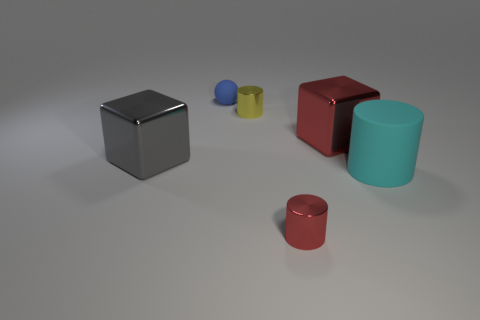Subtract all tiny cylinders. How many cylinders are left? 1 Add 1 large purple spheres. How many objects exist? 7 Subtract all cubes. How many objects are left? 4 Subtract 1 gray cubes. How many objects are left? 5 Subtract all blocks. Subtract all big gray metallic blocks. How many objects are left? 3 Add 6 big gray metallic objects. How many big gray metallic objects are left? 7 Add 5 large cylinders. How many large cylinders exist? 6 